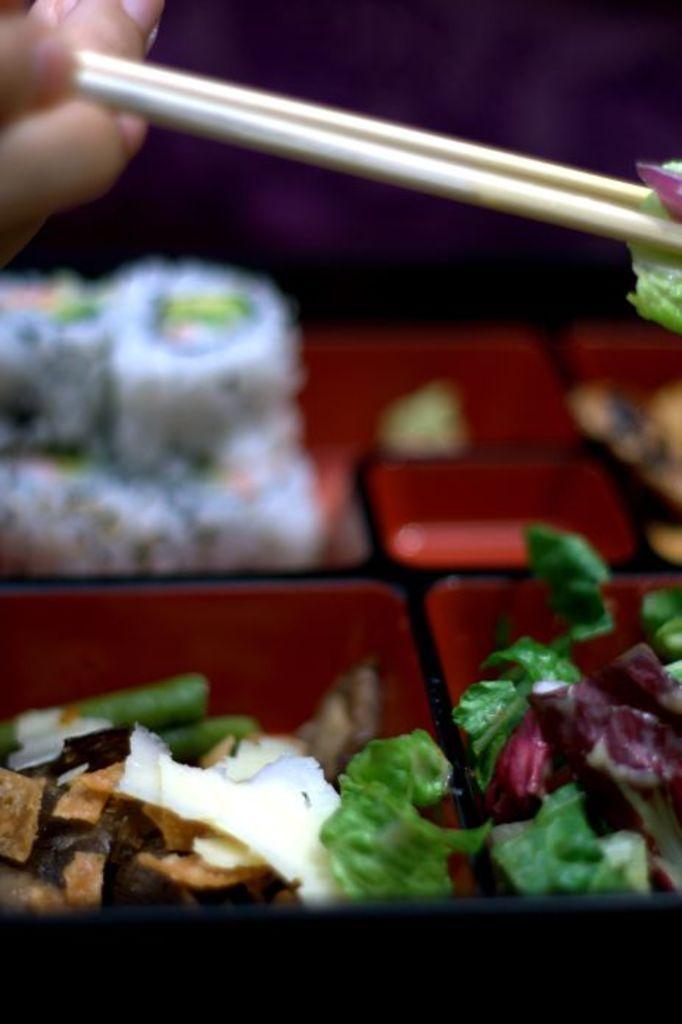How would you summarize this image in a sentence or two? In this image there is a box with a few food items in it and there is a hand of a person holding two chopsticks with a food item. 